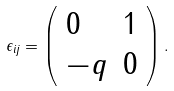<formula> <loc_0><loc_0><loc_500><loc_500>\epsilon _ { i j } = \left ( \begin{array} { l l } 0 & 1 \\ - q & 0 \end{array} \right ) .</formula> 